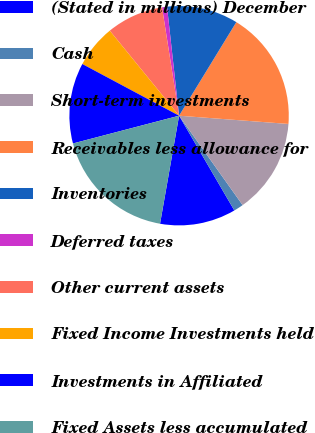Convert chart. <chart><loc_0><loc_0><loc_500><loc_500><pie_chart><fcel>(Stated in millions) December<fcel>Cash<fcel>Short-term investments<fcel>Receivables less allowance for<fcel>Inventories<fcel>Deferred taxes<fcel>Other current assets<fcel>Fixed Income Investments held<fcel>Investments in Affiliated<fcel>Fixed Assets less accumulated<nl><fcel>11.18%<fcel>1.43%<fcel>13.97%<fcel>17.46%<fcel>10.49%<fcel>0.73%<fcel>8.4%<fcel>6.31%<fcel>11.88%<fcel>18.15%<nl></chart> 